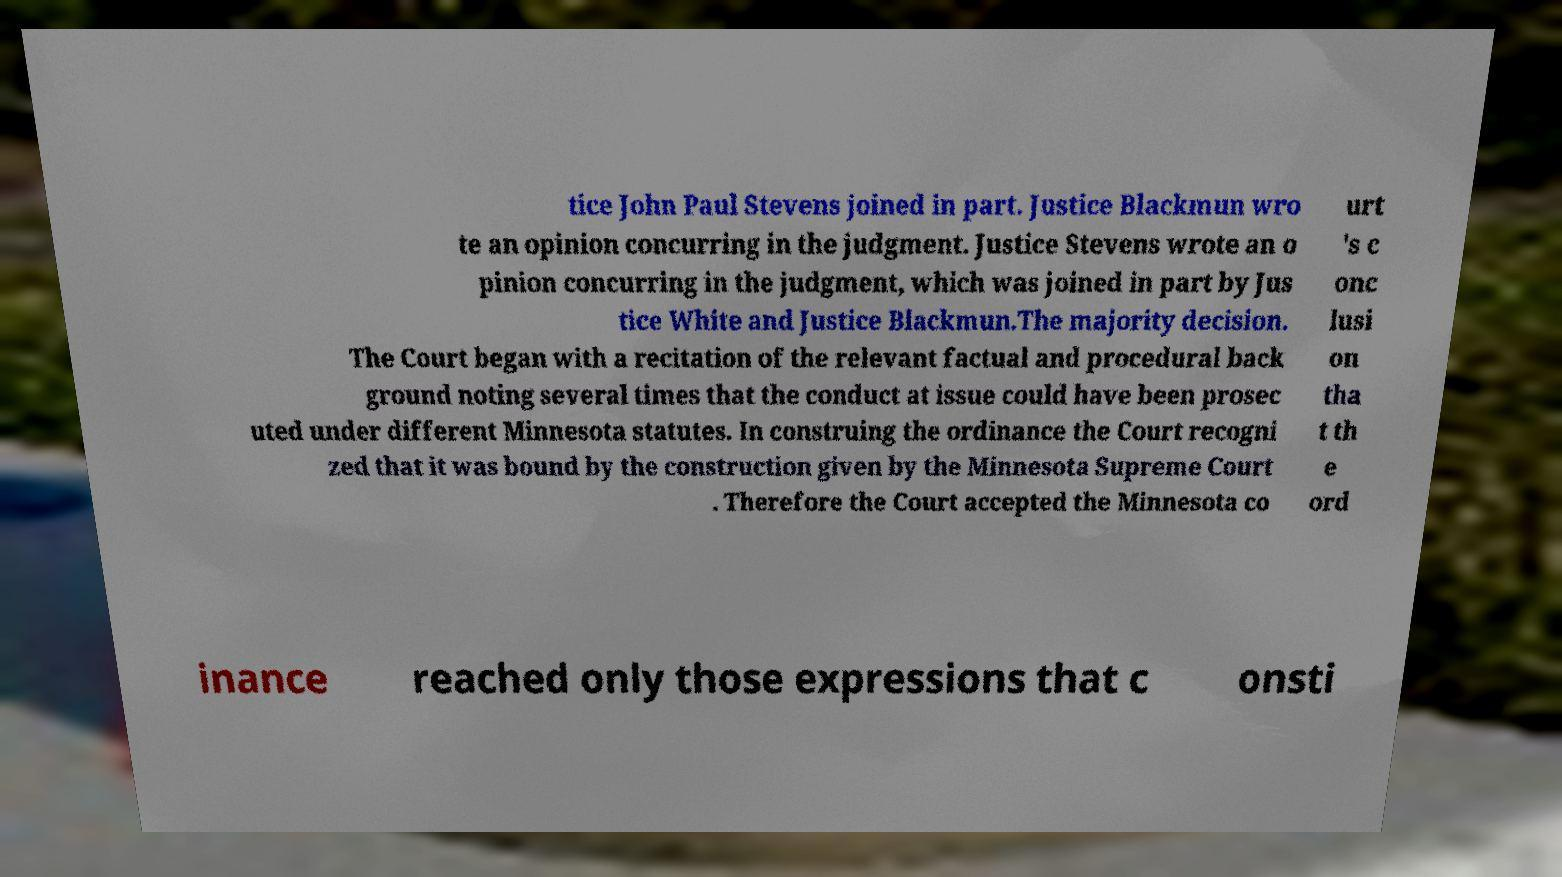Please identify and transcribe the text found in this image. tice John Paul Stevens joined in part. Justice Blackmun wro te an opinion concurring in the judgment. Justice Stevens wrote an o pinion concurring in the judgment, which was joined in part by Jus tice White and Justice Blackmun.The majority decision. The Court began with a recitation of the relevant factual and procedural back ground noting several times that the conduct at issue could have been prosec uted under different Minnesota statutes. In construing the ordinance the Court recogni zed that it was bound by the construction given by the Minnesota Supreme Court . Therefore the Court accepted the Minnesota co urt 's c onc lusi on tha t th e ord inance reached only those expressions that c onsti 